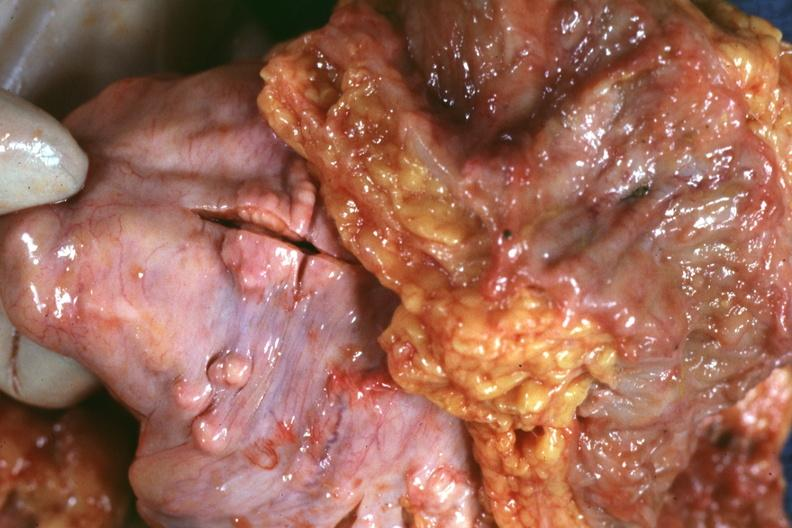s tuberculous peritonitis present?
Answer the question using a single word or phrase. No 